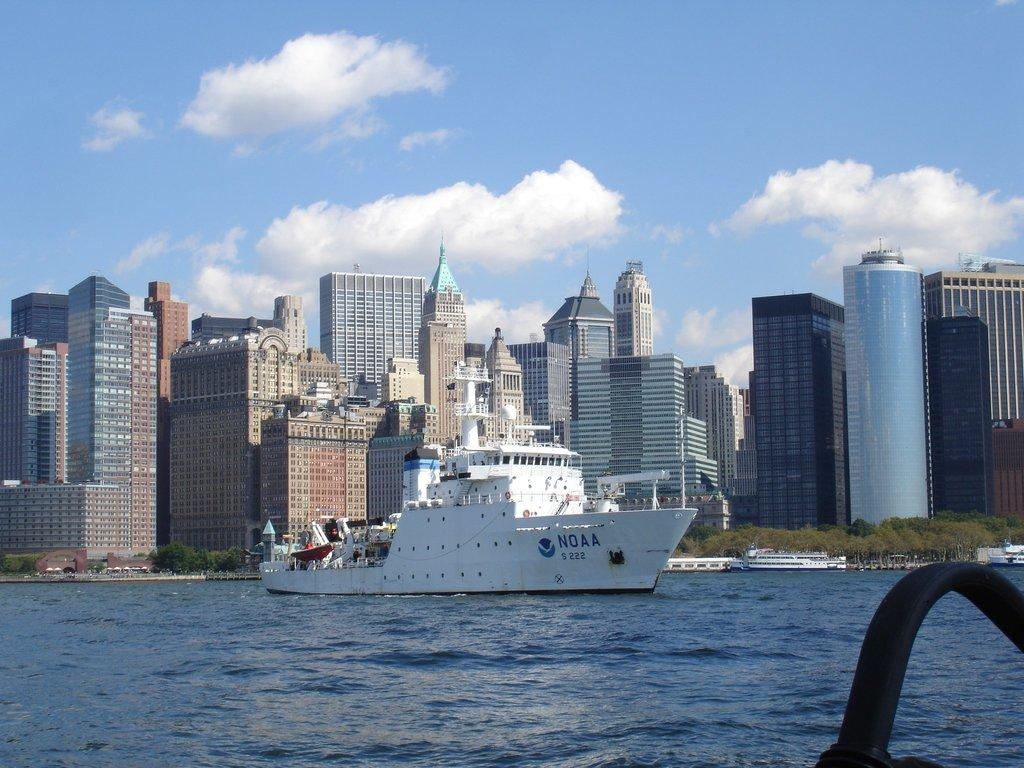What is the main subject in the center of the image? There is a ship in the center of the image. Where is the ship located? The ship is on the water. What can be seen at the bottom of the image? There is water visible at the bottom of the image. What else is present in the center of the image besides the ship? There are buildings in the center of the image. What is the size of the alley between the buildings in the image? There is no alley present between the buildings in the image. 